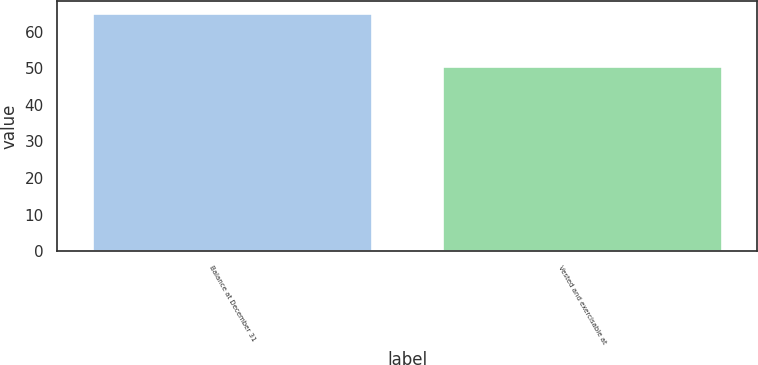Convert chart to OTSL. <chart><loc_0><loc_0><loc_500><loc_500><bar_chart><fcel>Balance at December 31<fcel>Vested and exercisable at<nl><fcel>64.98<fcel>50.72<nl></chart> 